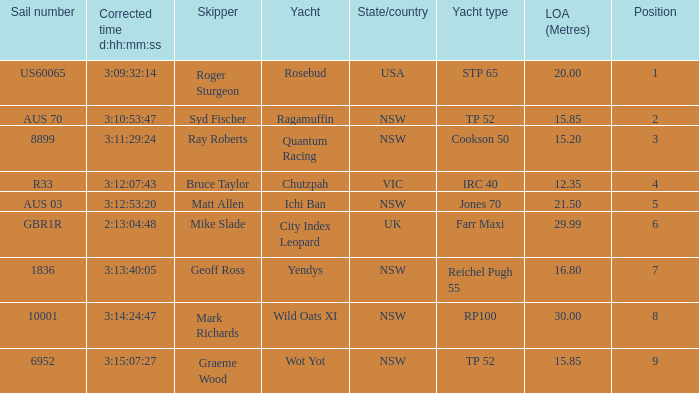Who were all of the skippers with a corrected time of 3:15:07:27? Graeme Wood. 